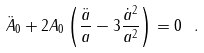Convert formula to latex. <formula><loc_0><loc_0><loc_500><loc_500>\ddot { A } _ { 0 } + 2 A _ { 0 } \left ( \frac { \ddot { a } } { a } - 3 \frac { \dot { a } ^ { 2 } } { a ^ { 2 } } \right ) = 0 \ .</formula> 